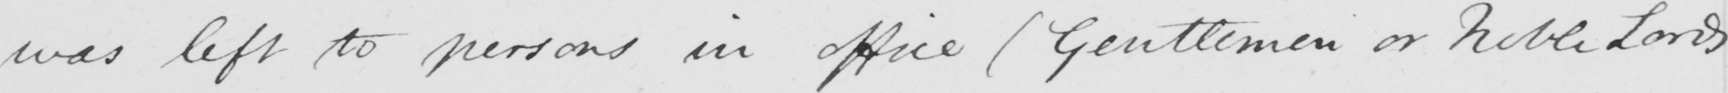Please transcribe the handwritten text in this image. was left to persons in office  ( Gentlemen or Noble Lords 